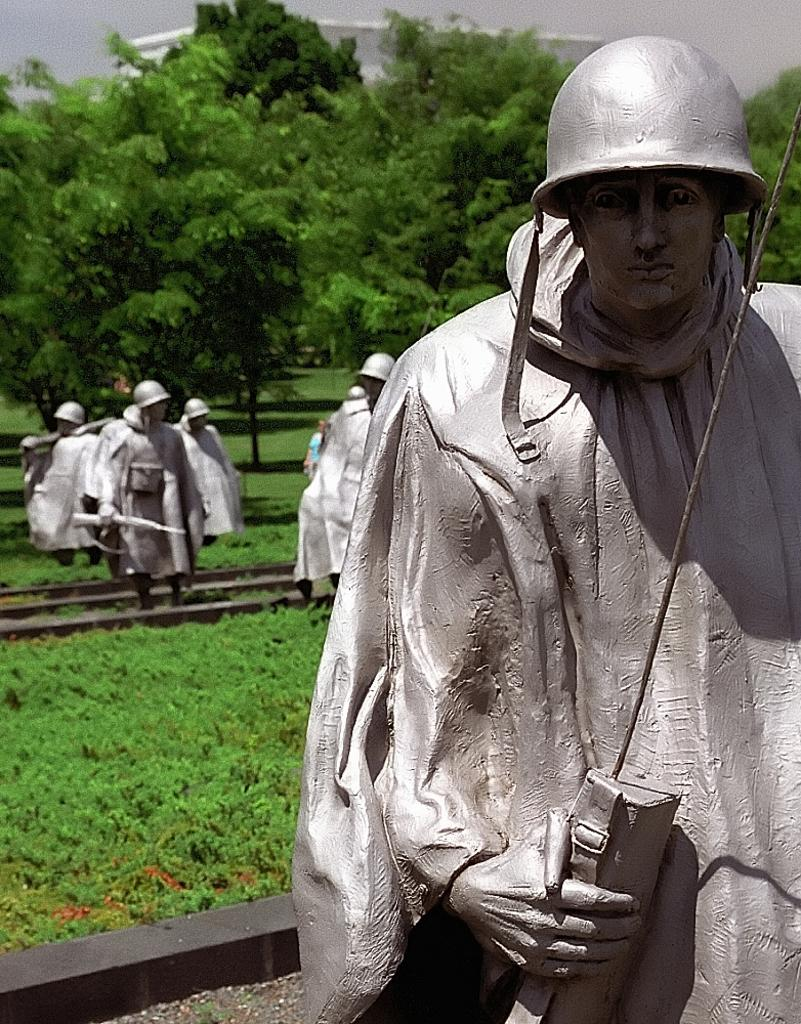What type of vegetation is present in the image? There is grass in the image. What are the sculptures in the image depicting? The sculptures in the image are of persons. What can be seen in the background of the image? There are trees, a building, and the sky visible in the background of the image. What is the behavior of the grandfather in the image? There is no grandfather present in the image; it features sculptures of persons. What is the size of the behavior in the image? The question is unclear and does not pertain to any aspect of the image. The image features sculptures, grass, trees, a building, and the sky, but it does not depict any behaviors or sizes of behaviors. 